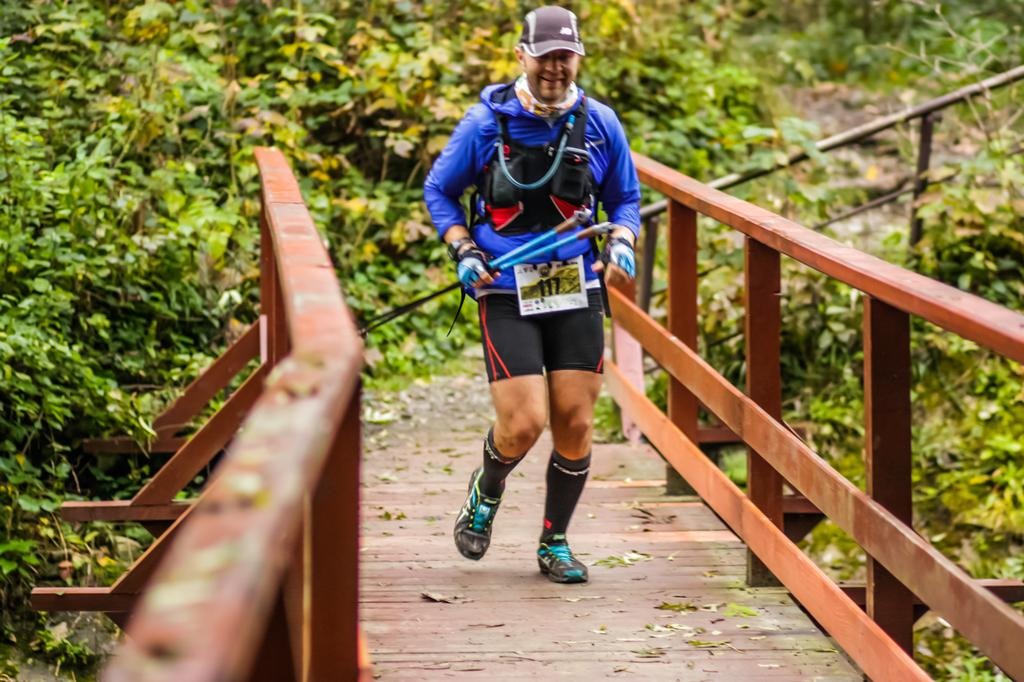Who or what is the main subject in the image? There is a person in the image. What is the person doing in the image? The person is walking on a bridge. What is the person holding in his hand? The person is holding two sticks in his hand. What can be seen in the background of the image? There are many trees and plants visible in the background of the image. Is the person walking towards a prison in the image? There is no prison visible in the image, and the person's destination is not mentioned or implied. 